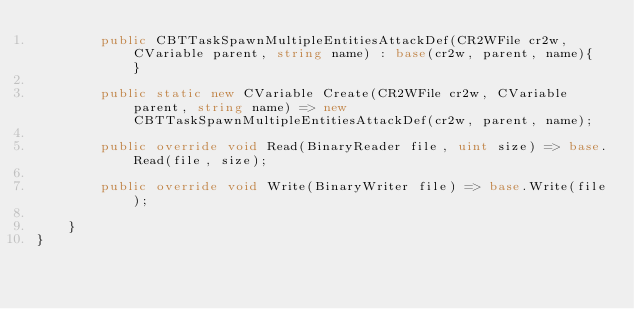<code> <loc_0><loc_0><loc_500><loc_500><_C#_>		public CBTTaskSpawnMultipleEntitiesAttackDef(CR2WFile cr2w, CVariable parent, string name) : base(cr2w, parent, name){ }

		public static new CVariable Create(CR2WFile cr2w, CVariable parent, string name) => new CBTTaskSpawnMultipleEntitiesAttackDef(cr2w, parent, name);

		public override void Read(BinaryReader file, uint size) => base.Read(file, size);

		public override void Write(BinaryWriter file) => base.Write(file);

	}
}</code> 